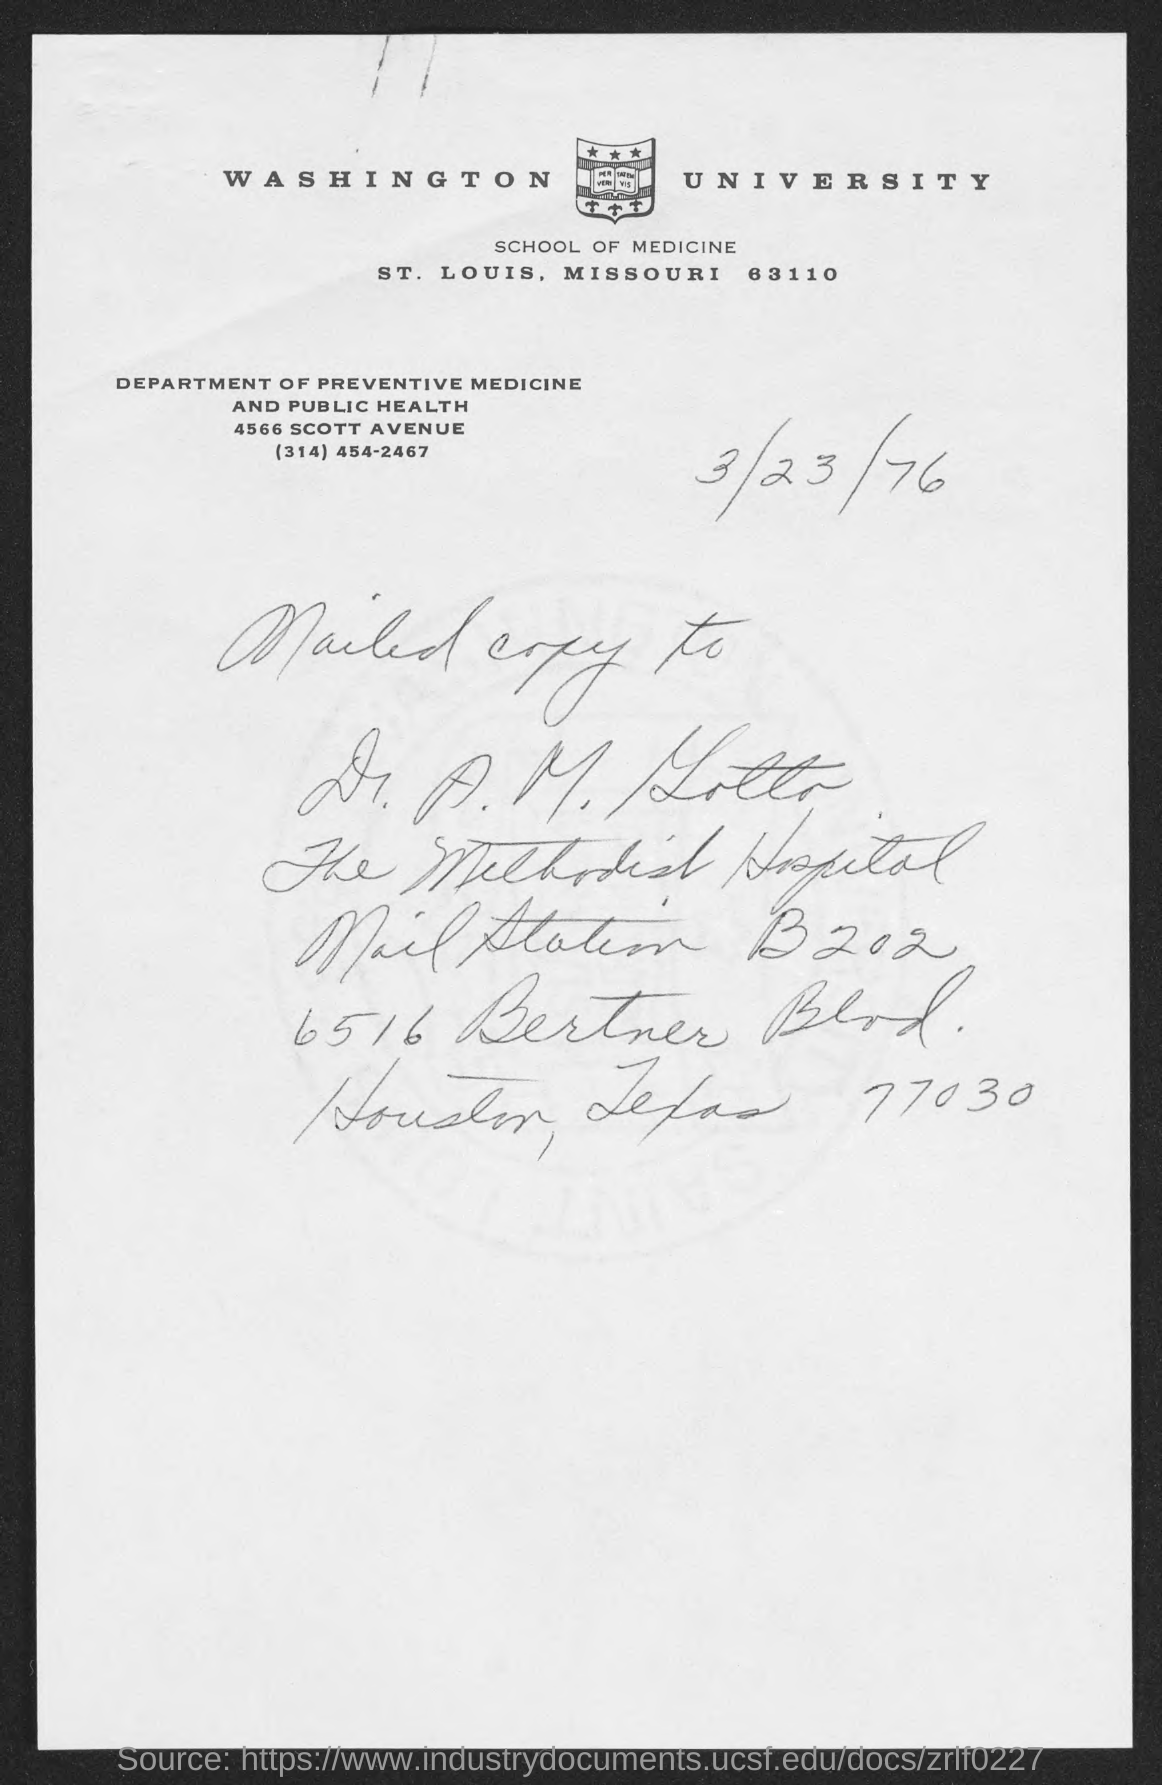What is the name of the university mentioned at top of page?
Offer a terse response. Washington university. What is the contact of department of preventive medicine and public health?
Offer a terse response. (314) 454-2467. 